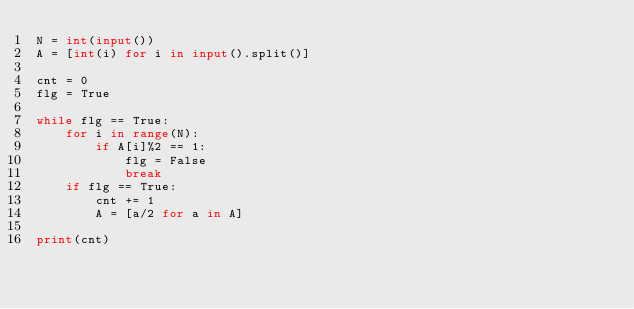<code> <loc_0><loc_0><loc_500><loc_500><_Python_>N = int(input())
A = [int(i) for i in input().split()]

cnt = 0
flg = True

while flg == True:
    for i in range(N):
        if A[i]%2 == 1:
            flg = False
            break
    if flg == True:
        cnt += 1
        A = [a/2 for a in A]

print(cnt)</code> 